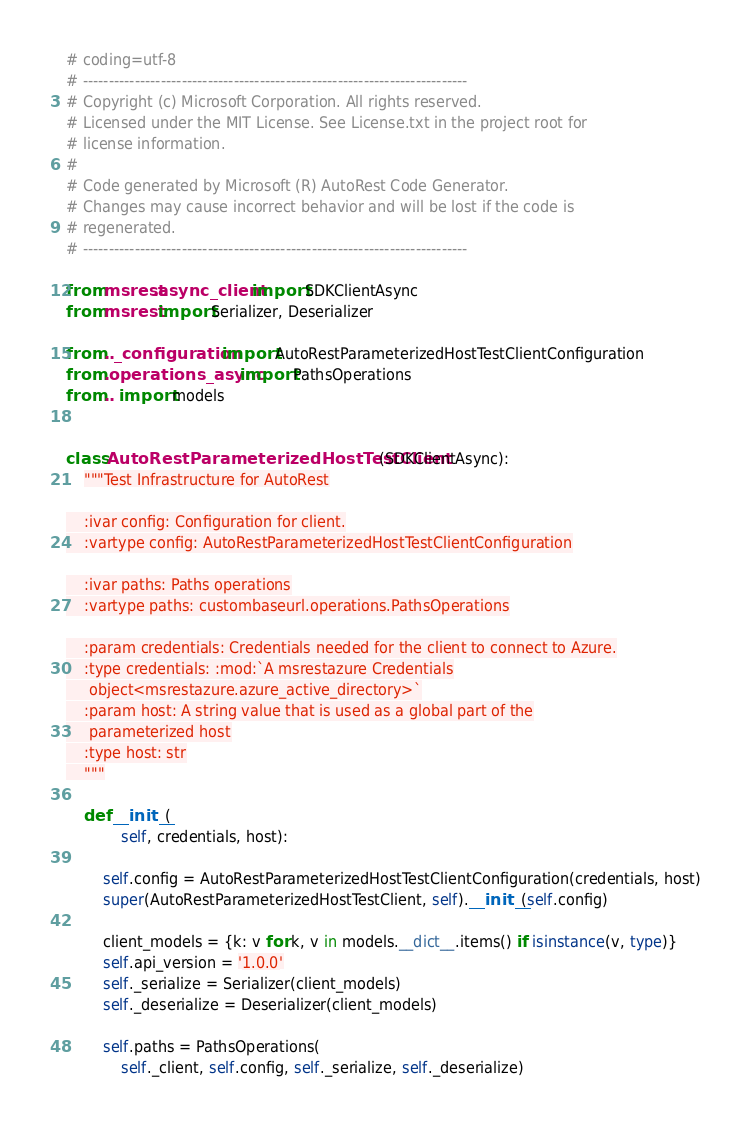Convert code to text. <code><loc_0><loc_0><loc_500><loc_500><_Python_># coding=utf-8
# --------------------------------------------------------------------------
# Copyright (c) Microsoft Corporation. All rights reserved.
# Licensed under the MIT License. See License.txt in the project root for
# license information.
#
# Code generated by Microsoft (R) AutoRest Code Generator.
# Changes may cause incorrect behavior and will be lost if the code is
# regenerated.
# --------------------------------------------------------------------------

from msrest.async_client import SDKClientAsync
from msrest import Serializer, Deserializer

from .._configuration import AutoRestParameterizedHostTestClientConfiguration
from .operations_async import PathsOperations
from .. import models


class AutoRestParameterizedHostTestClient(SDKClientAsync):
    """Test Infrastructure for AutoRest

    :ivar config: Configuration for client.
    :vartype config: AutoRestParameterizedHostTestClientConfiguration

    :ivar paths: Paths operations
    :vartype paths: custombaseurl.operations.PathsOperations

    :param credentials: Credentials needed for the client to connect to Azure.
    :type credentials: :mod:`A msrestazure Credentials
     object<msrestazure.azure_active_directory>`
    :param host: A string value that is used as a global part of the
     parameterized host
    :type host: str
    """

    def __init__(
            self, credentials, host):

        self.config = AutoRestParameterizedHostTestClientConfiguration(credentials, host)
        super(AutoRestParameterizedHostTestClient, self).__init__(self.config)

        client_models = {k: v for k, v in models.__dict__.items() if isinstance(v, type)}
        self.api_version = '1.0.0'
        self._serialize = Serializer(client_models)
        self._deserialize = Deserializer(client_models)

        self.paths = PathsOperations(
            self._client, self.config, self._serialize, self._deserialize)
</code> 